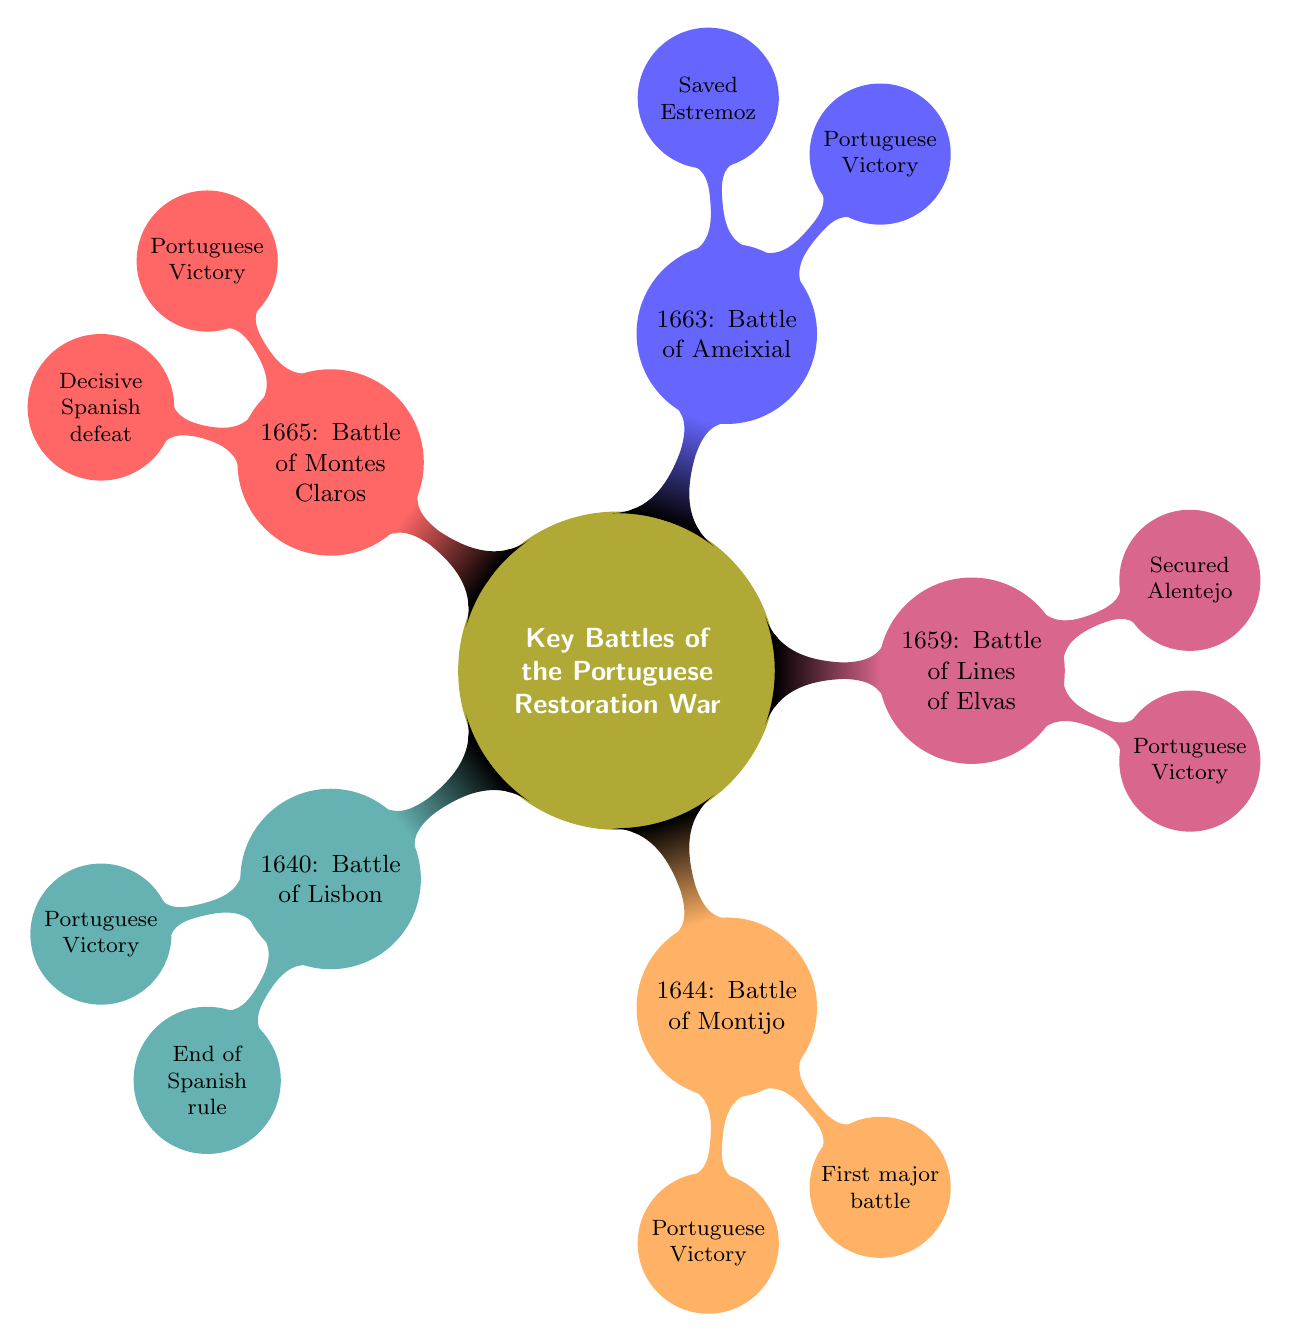What is the outcome of the Battle of Lisbon? The diagram states that the outcome of the Battle of Lisbon is "Portuguese Victory," which is mentioned directly under the corresponding battle node.
Answer: Portuguese Victory Which battle secured the Alentejo region? By tracing along the nodes, it is clear that the "Battle of Lines of Elvas" is the one that "Secured the Alentejo region," as indicated in the significance node beneath that battle.
Answer: Battle of Lines of Elvas How many battles are listed in the diagram? Counting the battles listed in the diagram, there are five specific battles: Lisbon, Montijo, Lines of Elvas, Ameixial, and Montes Claros.
Answer: 5 What was the significance of the Battle of Montes Claros? The significance of the Battle of Montes Claros, as per the diagram, is explicitly stated as "Decisive Spanish defeat," which can be found directly beneath that battle node.
Answer: Decisive Spanish defeat Who were the key commanders of the Battle of Ameixial? Referring to the Battle of Ameixial node, the key commanders are listed as "Frederick Schomberg" and "John of Austria the Younger."
Answer: Frederick Schomberg and John of Austria the Younger Which battle is known as the first major battle of the war? The diagram specifies that the "Battle of Montijo" is noted as the "First major battle of the war," connecting it to its significance and outcome.
Answer: Battle of Montijo What year did the Battle of Montes Claros occur? The node for the "Battle of Montes Claros" specifies the year as "1665," providing a direct answer located within the diagram's structure.
Answer: 1665 What does the Battle of Lisbon signify? The significance node for the Battle of Lisbon states that it marks the "End of Spanish rule," which is a key aspect of the battle's importance.
Answer: End of Spanish rule 